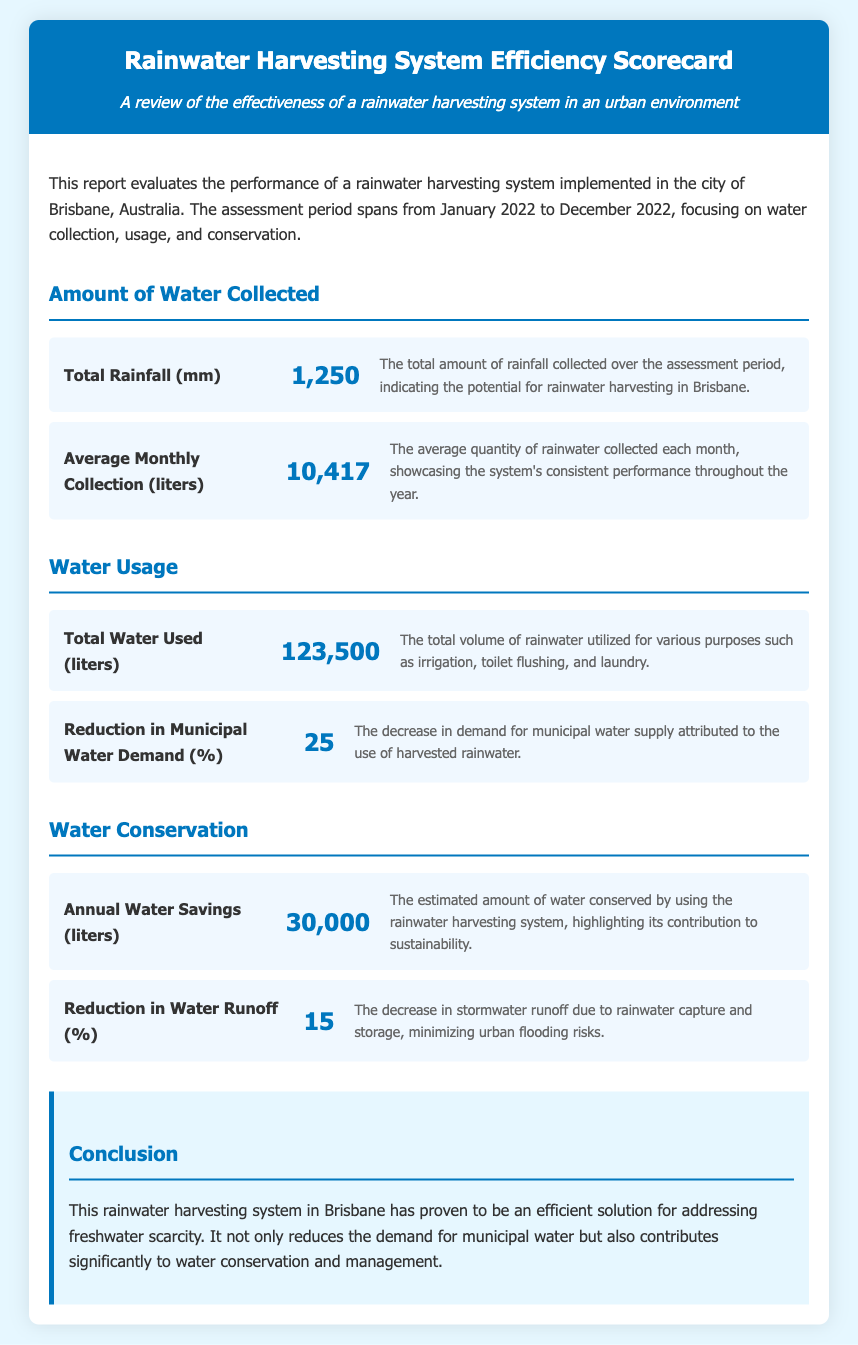What is the total rainfall collected over the assessment period? The total rainfall collected is specified to indicate the potential for rainwater harvesting, which is 1,250 mm.
Answer: 1,250 mm What is the average monthly collection? The average monthly collection showcases the system's consistent performance throughout the year, which is 10,417 liters.
Answer: 10,417 liters What is the total water used during the assessment period? The total volume of rainwater utilized for various purposes is stated to be 123,500 liters.
Answer: 123,500 liters What percentage reduction in municipal water demand was achieved? The decrease in demand for municipal water supply attributed to the use of harvested rainwater is noted to be 25%.
Answer: 25% What are the annual water savings estimated at? The estimated amount of water conserved by using the rainwater harvesting system is highlighted as 30,000 liters.
Answer: 30,000 liters What was the reduction in water runoff? The decrease in stormwater runoff due to rainwater capture and storage is specified as 15%.
Answer: 15% What city is the rainwater harvesting system implemented in? The report specifies the implementation location of the rainwater harvesting system as Brisbane, Australia.
Answer: Brisbane, Australia What year did the assessment period span? The assessment period for the rainwater harvesting system is mentioned to range across the entirety of 2022.
Answer: 2022 What is the conclusion regarding the rainwater harvesting system's efficiency? The conclusion states that the system has proven to be an efficient solution for addressing freshwater scarcity.
Answer: Efficient solution for addressing freshwater scarcity 